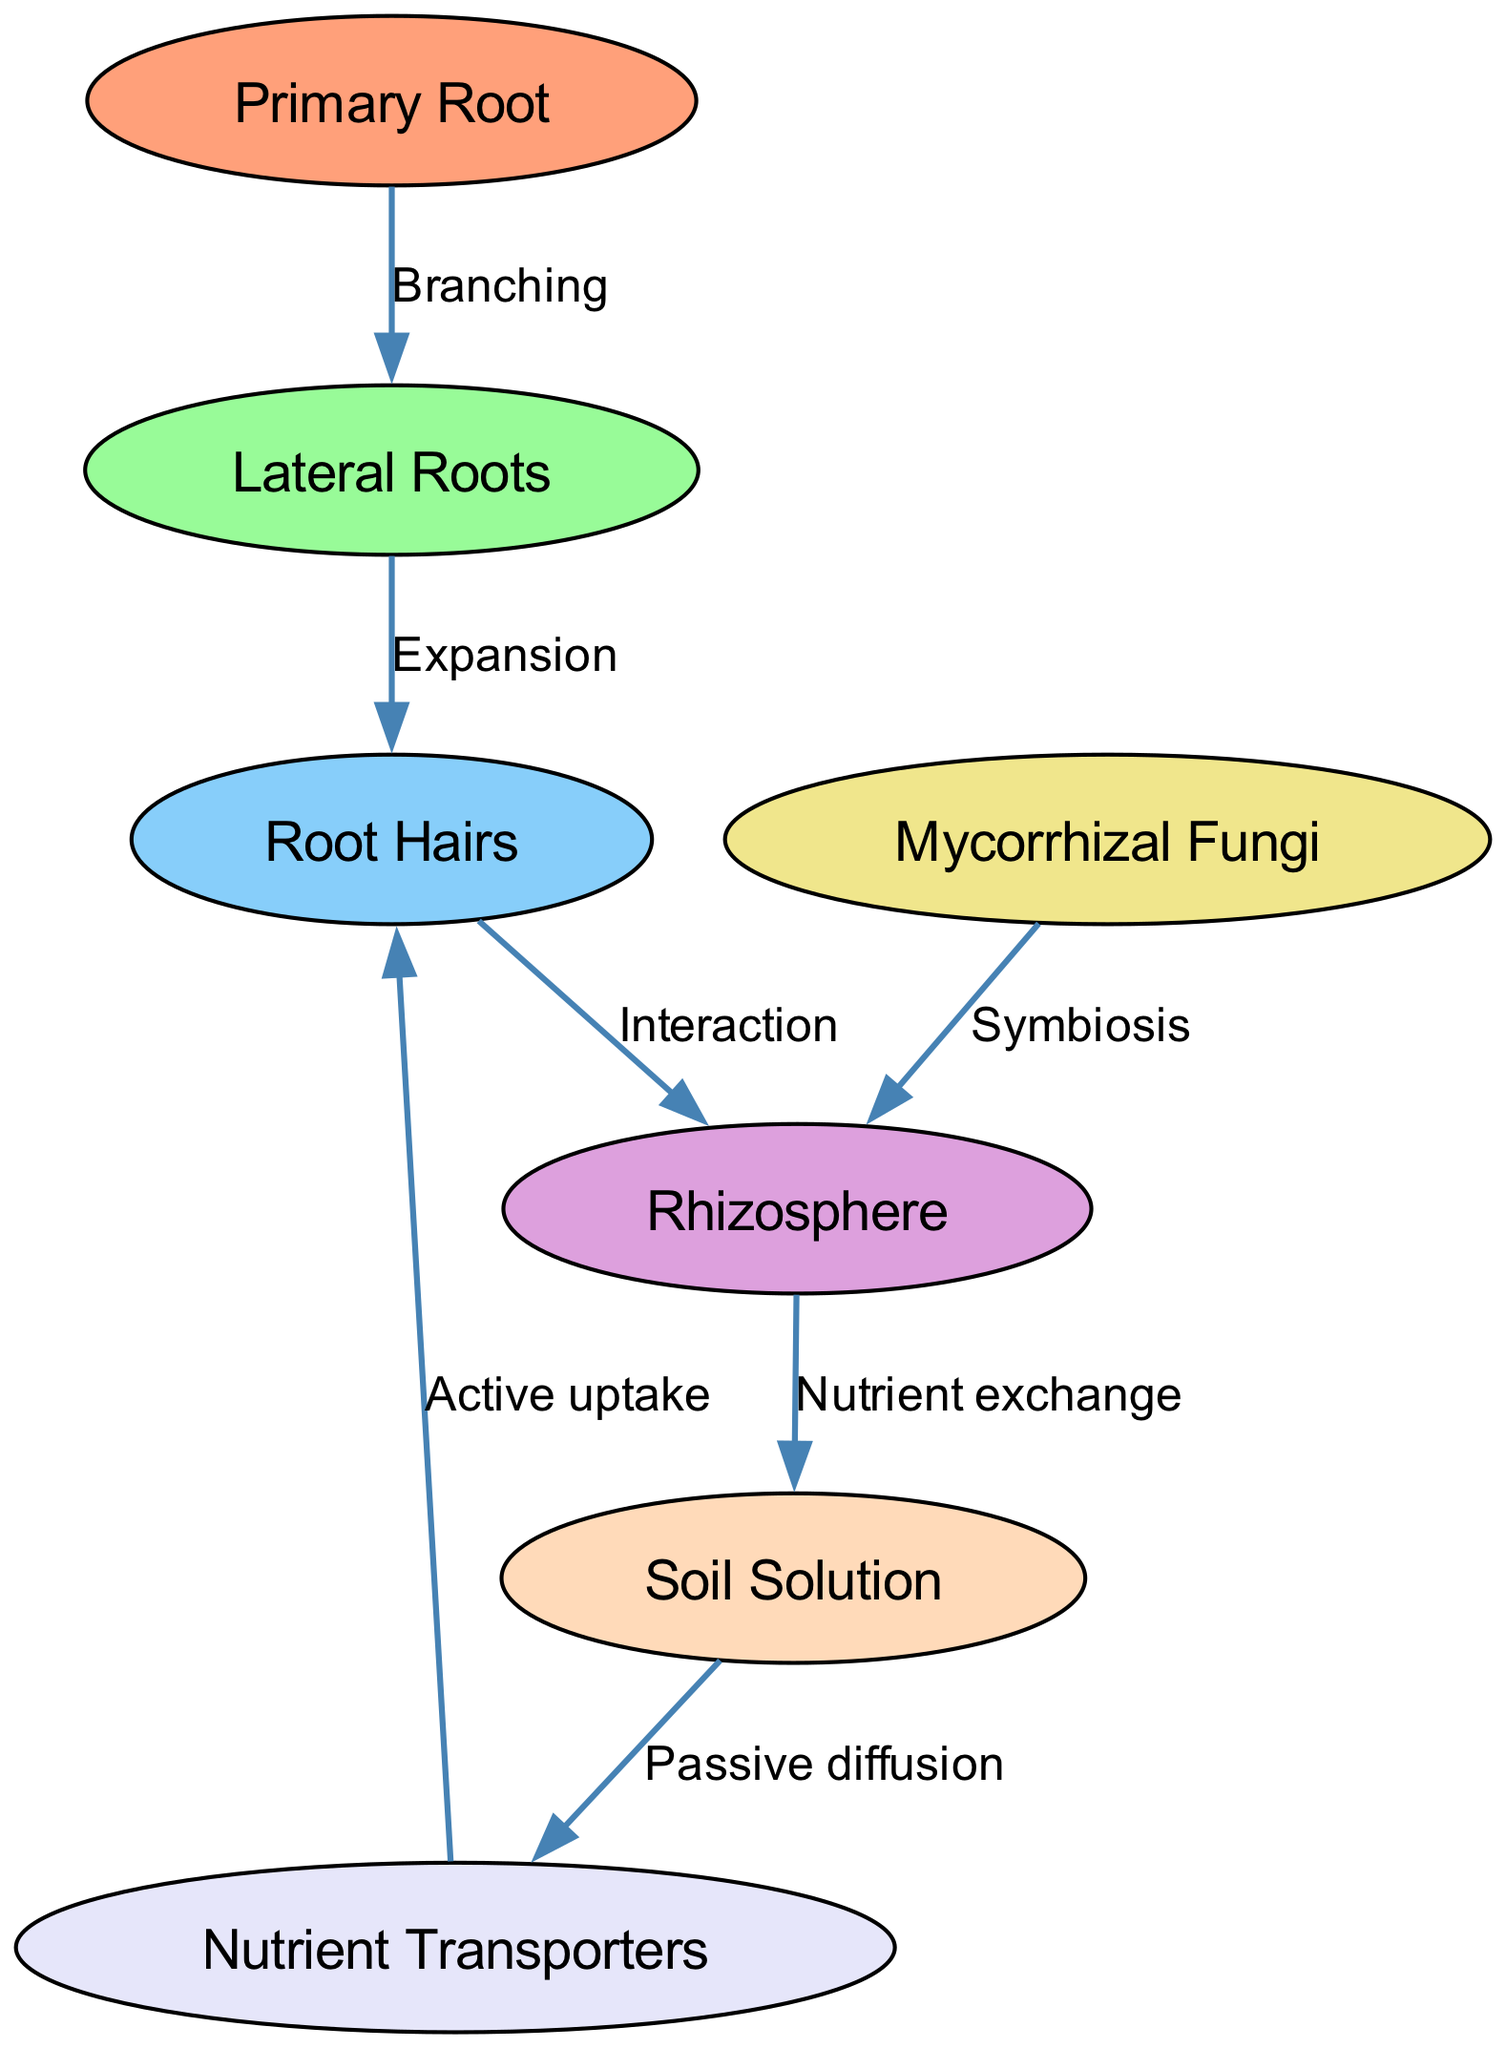What is the primary root connected to? The primary root is connected to lateral roots, as shown by the "Branching" edge labeled in the diagram.
Answer: Lateral Roots How many nodes are present in the diagram? There are seven nodes according to the total count of unique elements listed in the diagram data.
Answer: Seven What type of interaction occurs between root hairs and the rhizosphere? The interaction between root hairs and the rhizosphere is defined by the "Interaction" edge labeled in the diagram.
Answer: Interaction Which node represents the active uptake of nutrients? The active uptake of nutrients is represented by the node "Nutrient Transporters," which is connected to root hairs.
Answer: Nutrient Transporters What is the relationship between mycorrhizal fungi and the rhizosphere? The relationship is characterized by the "Symbiosis" edge connecting mycorrhizal fungi to the rhizosphere, indicating a mutual interaction.
Answer: Symbiosis Which mechanism allows nutrients to pass from the soil solution to nutrient transporters? The mechanism that allows nutrients to pass is "Passive diffusion," which is depicted as an edge between the soil solution and nutrient transporters.
Answer: Passive diffusion How many edges are there in total in the diagram? The total number of edges can be counted from the provided edges, resulting in a total of six connections between nodes.
Answer: Six What connects lateral roots to root hairs? Lateral roots are connected to root hairs through the process termed "Expansion," indicating growth and development from lateral roots to root hairs.
Answer: Expansion Which node shows the process of nutrient exchange with the soil solution? The process of nutrient exchange is depicted with the edge connecting the rhizosphere to the soil solution, illustrating the flow of nutrients.
Answer: Nutrient exchange 